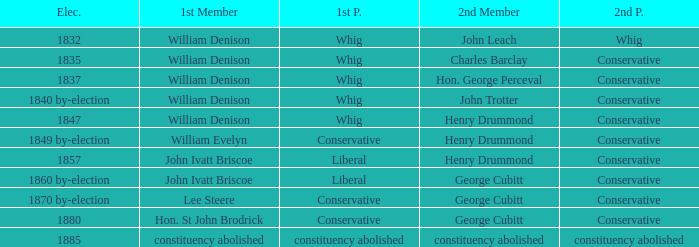Which party's 1st member is John Ivatt Briscoe in an election in 1857? Liberal. Write the full table. {'header': ['Elec.', '1st Member', '1st P.', '2nd Member', '2nd P.'], 'rows': [['1832', 'William Denison', 'Whig', 'John Leach', 'Whig'], ['1835', 'William Denison', 'Whig', 'Charles Barclay', 'Conservative'], ['1837', 'William Denison', 'Whig', 'Hon. George Perceval', 'Conservative'], ['1840 by-election', 'William Denison', 'Whig', 'John Trotter', 'Conservative'], ['1847', 'William Denison', 'Whig', 'Henry Drummond', 'Conservative'], ['1849 by-election', 'William Evelyn', 'Conservative', 'Henry Drummond', 'Conservative'], ['1857', 'John Ivatt Briscoe', 'Liberal', 'Henry Drummond', 'Conservative'], ['1860 by-election', 'John Ivatt Briscoe', 'Liberal', 'George Cubitt', 'Conservative'], ['1870 by-election', 'Lee Steere', 'Conservative', 'George Cubitt', 'Conservative'], ['1880', 'Hon. St John Brodrick', 'Conservative', 'George Cubitt', 'Conservative'], ['1885', 'constituency abolished', 'constituency abolished', 'constituency abolished', 'constituency abolished']]} 